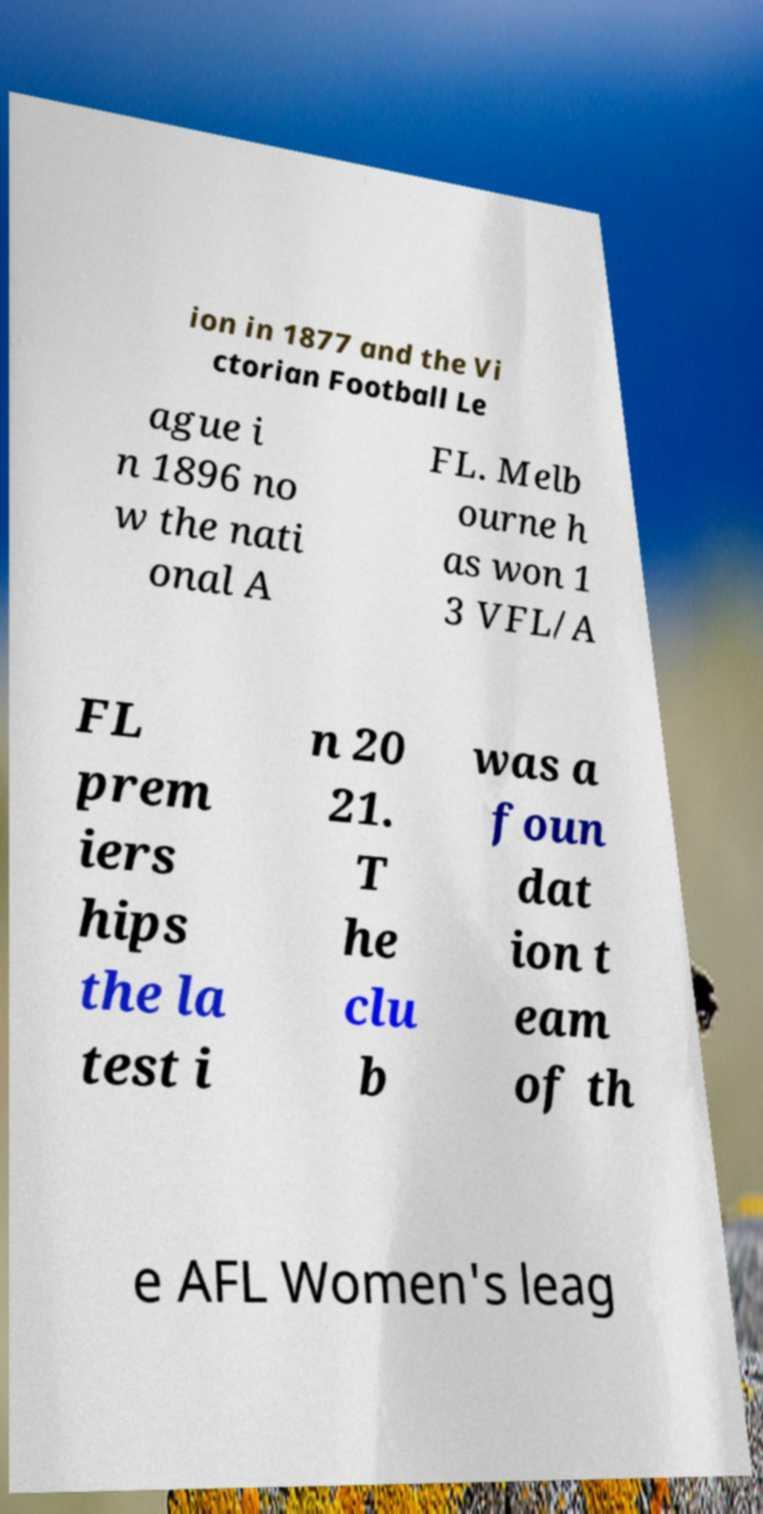For documentation purposes, I need the text within this image transcribed. Could you provide that? ion in 1877 and the Vi ctorian Football Le ague i n 1896 no w the nati onal A FL. Melb ourne h as won 1 3 VFL/A FL prem iers hips the la test i n 20 21. T he clu b was a foun dat ion t eam of th e AFL Women's leag 